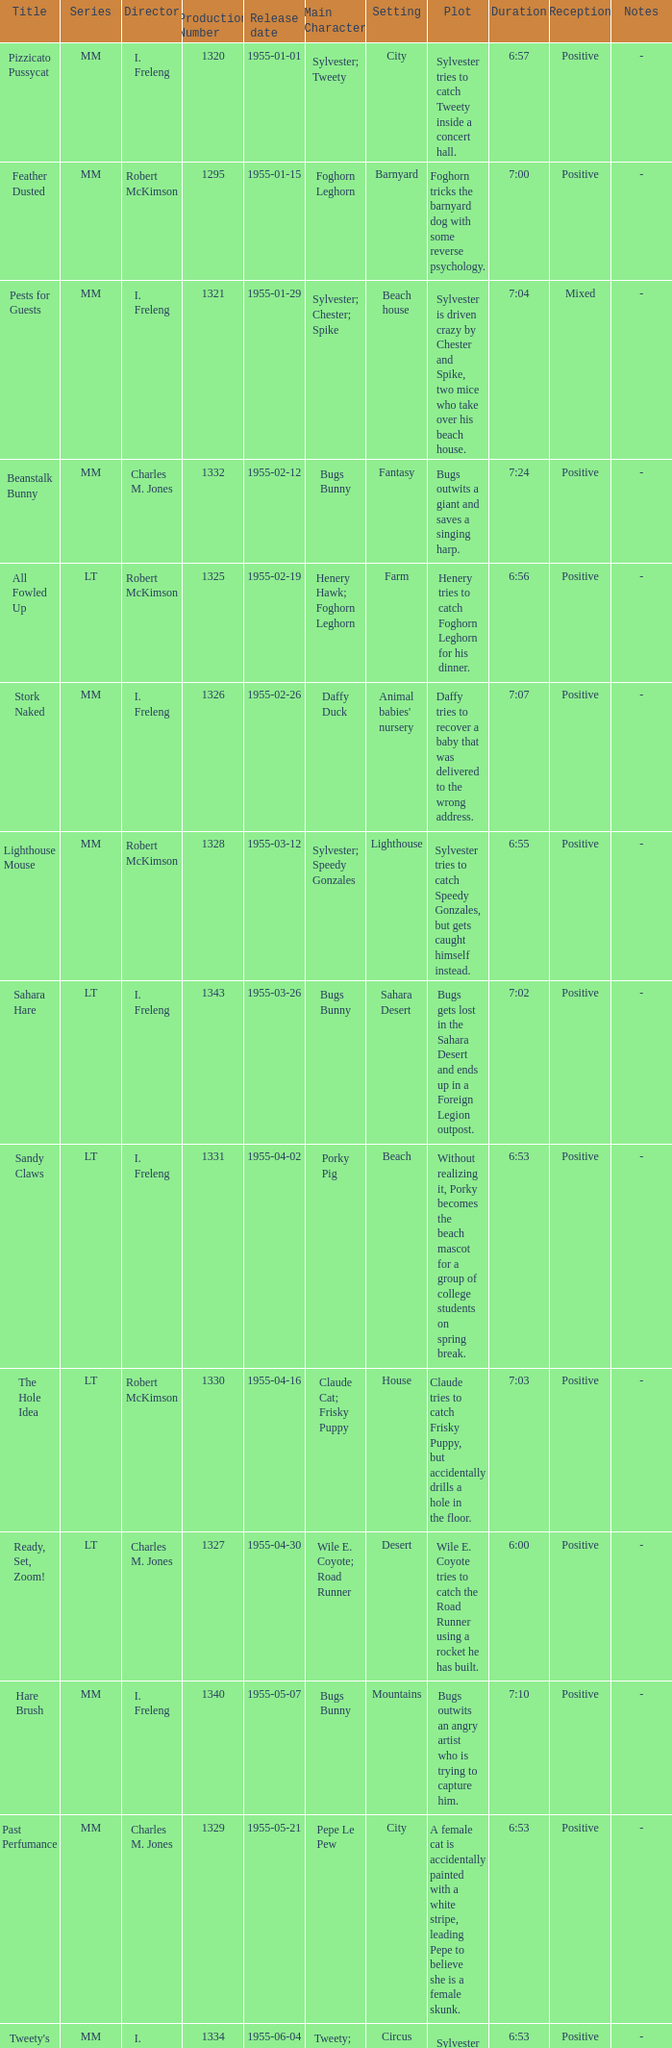Can you parse all the data within this table? {'header': ['Title', 'Series', 'Director', 'Production Number', 'Release date', 'Main Character', 'Setting', 'Plot', 'Duration', 'Reception', 'Notes'], 'rows': [['Pizzicato Pussycat', 'MM', 'I. Freleng', '1320', '1955-01-01', 'Sylvester; Tweety', 'City', 'Sylvester tries to catch Tweety inside a concert hall.', '6:57', 'Positive', '-'], ['Feather Dusted', 'MM', 'Robert McKimson', '1295', '1955-01-15', 'Foghorn Leghorn', 'Barnyard', 'Foghorn tricks the barnyard dog with some reverse psychology.', '7:00', 'Positive', '-'], ['Pests for Guests', 'MM', 'I. Freleng', '1321', '1955-01-29', 'Sylvester; Chester; Spike', 'Beach house', 'Sylvester is driven crazy by Chester and Spike, two mice who take over his beach house.', '7:04', 'Mixed', '-'], ['Beanstalk Bunny', 'MM', 'Charles M. Jones', '1332', '1955-02-12', 'Bugs Bunny', 'Fantasy', 'Bugs outwits a giant and saves a singing harp.', '7:24', 'Positive', '-'], ['All Fowled Up', 'LT', 'Robert McKimson', '1325', '1955-02-19', 'Henery Hawk; Foghorn Leghorn', 'Farm', 'Henery tries to catch Foghorn Leghorn for his dinner.', '6:56', 'Positive', '-'], ['Stork Naked', 'MM', 'I. Freleng', '1326', '1955-02-26', 'Daffy Duck', "Animal babies' nursery", 'Daffy tries to recover a baby that was delivered to the wrong address.', '7:07', 'Positive', '-'], ['Lighthouse Mouse', 'MM', 'Robert McKimson', '1328', '1955-03-12', 'Sylvester; Speedy Gonzales', 'Lighthouse', 'Sylvester tries to catch Speedy Gonzales, but gets caught himself instead.', '6:55', 'Positive', '-'], ['Sahara Hare', 'LT', 'I. Freleng', '1343', '1955-03-26', 'Bugs Bunny', 'Sahara Desert', 'Bugs gets lost in the Sahara Desert and ends up in a Foreign Legion outpost.', '7:02', 'Positive', '-'], ['Sandy Claws', 'LT', 'I. Freleng', '1331', '1955-04-02', 'Porky Pig', 'Beach', 'Without realizing it, Porky becomes the beach mascot for a group of college students on spring break.', '6:53', 'Positive', '-'], ['The Hole Idea', 'LT', 'Robert McKimson', '1330', '1955-04-16', 'Claude Cat; Frisky Puppy', 'House', 'Claude tries to catch Frisky Puppy, but accidentally drills a hole in the floor.', '7:03', 'Positive', '-'], ['Ready, Set, Zoom!', 'LT', 'Charles M. Jones', '1327', '1955-04-30', 'Wile E. Coyote; Road Runner', 'Desert', 'Wile E. Coyote tries to catch the Road Runner using a rocket he has built.', '6:00', 'Positive', '-'], ['Hare Brush', 'MM', 'I. Freleng', '1340', '1955-05-07', 'Bugs Bunny', 'Mountains', 'Bugs outwits an angry artist who is trying to capture him.', '7:10', 'Positive', '-'], ['Past Perfumance', 'MM', 'Charles M. Jones', '1329', '1955-05-21', 'Pepe Le Pew', 'City', 'A female cat is accidentally painted with a white stripe, leading Pepe to believe she is a female skunk.', '6:53', 'Positive', '-'], ["Tweety's Circus", 'MM', 'I. Freleng', '1334', '1955-06-04', 'Tweety; Sylvester', 'Circus', 'Sylvester tries to catch Tweety at the circus, but ends up causing chaos.', '6:53', 'Positive', '-'], ['Rabbit Rampage', 'LT', 'Charles M. Jones', '1341', '1955-06-11', 'Bugs Bunny; Daffy Duck', 'City', 'Daffy is tormented by an animator who keeps changing his appearance.', '7:20', 'Positive', '-'], ['Lumber Jerks', 'LT', 'I. Freleng', '1305', '1955-06-25', 'Goofy Gophers', 'Forest', "The Goofy Gophers' tree home is destroyed and they move into a lumberyard.", '6:17', 'Positive', '-'], ['This Is a Life?', 'MM', 'I. Freleng', '1342', '1955-07-09', 'Bugs Bunny; Elmer Fudd', 'Jungle', 'Bugs and Elmer crash-land in the jungle and have to survive against various animals.', '7:02', 'Positive', '-'], ['Double or Mutton', 'LT', 'Charles M. Jones', '1343', '1955-07-23', 'Ralph Wolf; Sam Sheepdog', 'Sheep ranch', 'Ralph tries to steal the sheep, but Sam is always one step ahead of him.', '6:52', 'Positive', '-'], ["Jumpin' Jupiter", 'MM', 'Charles M. Jones', '1338', '1955-08-06', 'Marvin the Martian; Bugs Bunny', 'Outer space', 'Marvin tries to blow up the Earth with his Iludium Q-36 Space Modulator, but Bugs outsmarts him.', '7:04', 'Positive', '-'], ["A Kiddie's Kitty", 'MM', 'I. Freleng', '1350', '1955-08-20', 'Sylvester; Granny; Hippety Hopper', 'City apartment', 'Sylvester mistakes Hippety Hopper, a baby kangaroo, for a giant mouse.', '7:10', 'Positive', '-'], ['Hyde and Hare', 'LT', 'I. Freleng', '1339', '1955-08-27', 'Bugs Bunny', 'City', "Bugs gets mixed up with Dr. Jekyll's potion and turns into a monster.", '7:00', 'Positive', '-'], ['Dime to Retire', 'LT', 'Robert McKimson', '1333', '1955-09-03', 'Speedy Gonzales', 'Town', 'Speedy tries to protect his mice friends from a vicious cat.', '6:52', 'Positive', '-'], ['Speedy Gonzales', 'MM', 'I. Freleng', '1345', '1955-09-17', 'Speedy Gonzales', 'Mexico', 'Speedy outwits Sylvester, who is guarding a cheese factory.', '6:57', 'Positive', '-'], ['Knight-mare Hare', 'MM', 'Chuck Jones', '1349', '1955-10-01', 'Bugs Bunny', 'Fantasy', 'Bugs becomes the court jester of King Arthur and his knights.', '7:16', 'Positive', '-'], ["Two Scent's Worth", 'MM', 'Charles M. Jones', '1377', '1955-10-15', 'Pepe Le Pew; Penelope Pussycat', 'Paris', 'Pepe mistakes Penelope for a female skunk and relentlessly pursues her in Paris.', '6:59', 'Positive', '-'], ['Red Riding Hoodwinked', 'LT', 'I. Freleng', '1346', '1955-10-29', 'Bugs Bunny; Big Bad Wolf', 'Forest', 'Bugs helps Little Red Riding Hood outsmart the Big Bad Wolf.', '7:02', 'Positive', '-'], ['Roman Legion-Hare', 'LT', 'Friz Freleng', '1384', '1955-11-12', 'Bugs Bunny', 'Ancient Rome', 'Bugs becomes a gladiator in ancient Rome and outwits his opponents.', '7:00', 'Positive', '-'], ['Heir-Conditioned', 'LT', 'Friz Freleng', '1393', '1955-11-26', 'Sylvester; Elmer Fudd', 'Mansion', 'Sylvester tries to catch Tweety in a mansion, but is outsmarted by the bird and Elmer.', '7:17', 'Positive', '-'], ['Guided Muscle', 'LT', 'Charles M. Jones', '1344', '1955-12-10', 'Wile E. Coyote; Road Runner', 'Desert', 'Wile E. Coyote uses a guided missile to try and catch the Road Runner.', '6:22', 'Positive', '-'], ["Pappy's Puppy", 'MM', 'Friz Freleng', '1378', '1955-12-17', 'Sylvester; Hippety Hopper', 'City apartment', 'Sylvester tries to catch Hippety Hopper, who has been adopted as a pet by an old lady.', '7:20', 'Positive', '-'], ['One Froggy Evening', 'MM', 'Charles M. Jones', '1335', '1955-12-31', 'Michigan J. Frog', 'City', "A man discovers a singing and dancing frog, but can't seem to get anyone to believe him.", '7:56', 'Positive', '-']]} What is the release date of production number 1327? 1955-04-30. 